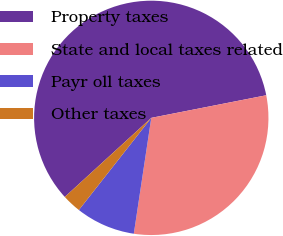<chart> <loc_0><loc_0><loc_500><loc_500><pie_chart><fcel>Property taxes<fcel>State and local taxes related<fcel>Payr oll taxes<fcel>Other taxes<nl><fcel>58.7%<fcel>30.47%<fcel>8.22%<fcel>2.61%<nl></chart> 